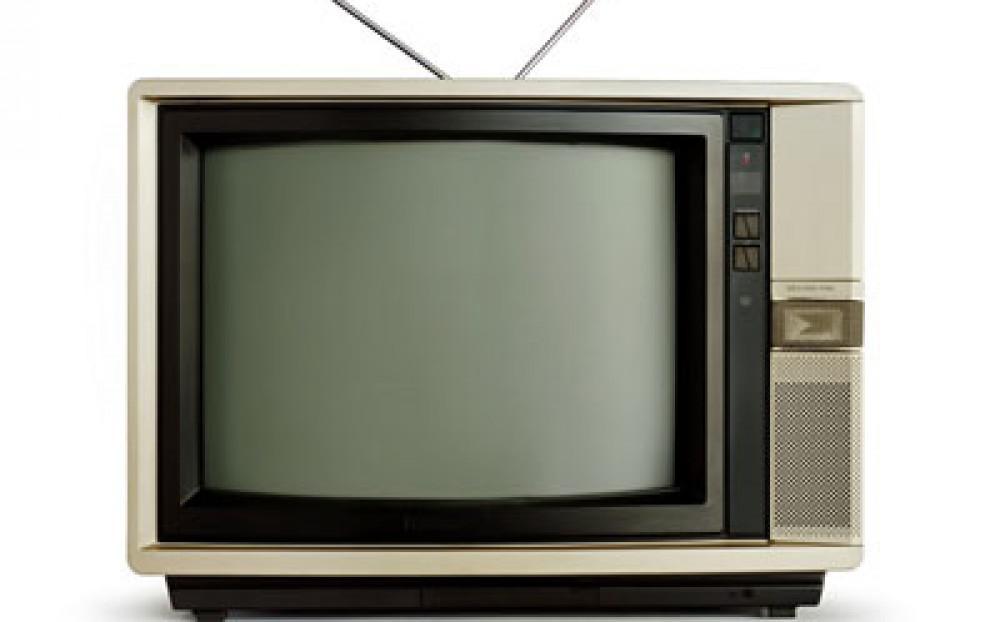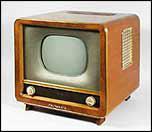The first image is the image on the left, the second image is the image on the right. For the images shown, is this caption "The right image contains one flat screen television that is turned off." true? Answer yes or no. No. 